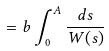<formula> <loc_0><loc_0><loc_500><loc_500>= b \int _ { 0 } ^ { A } \frac { d s } { W ( s ) }</formula> 